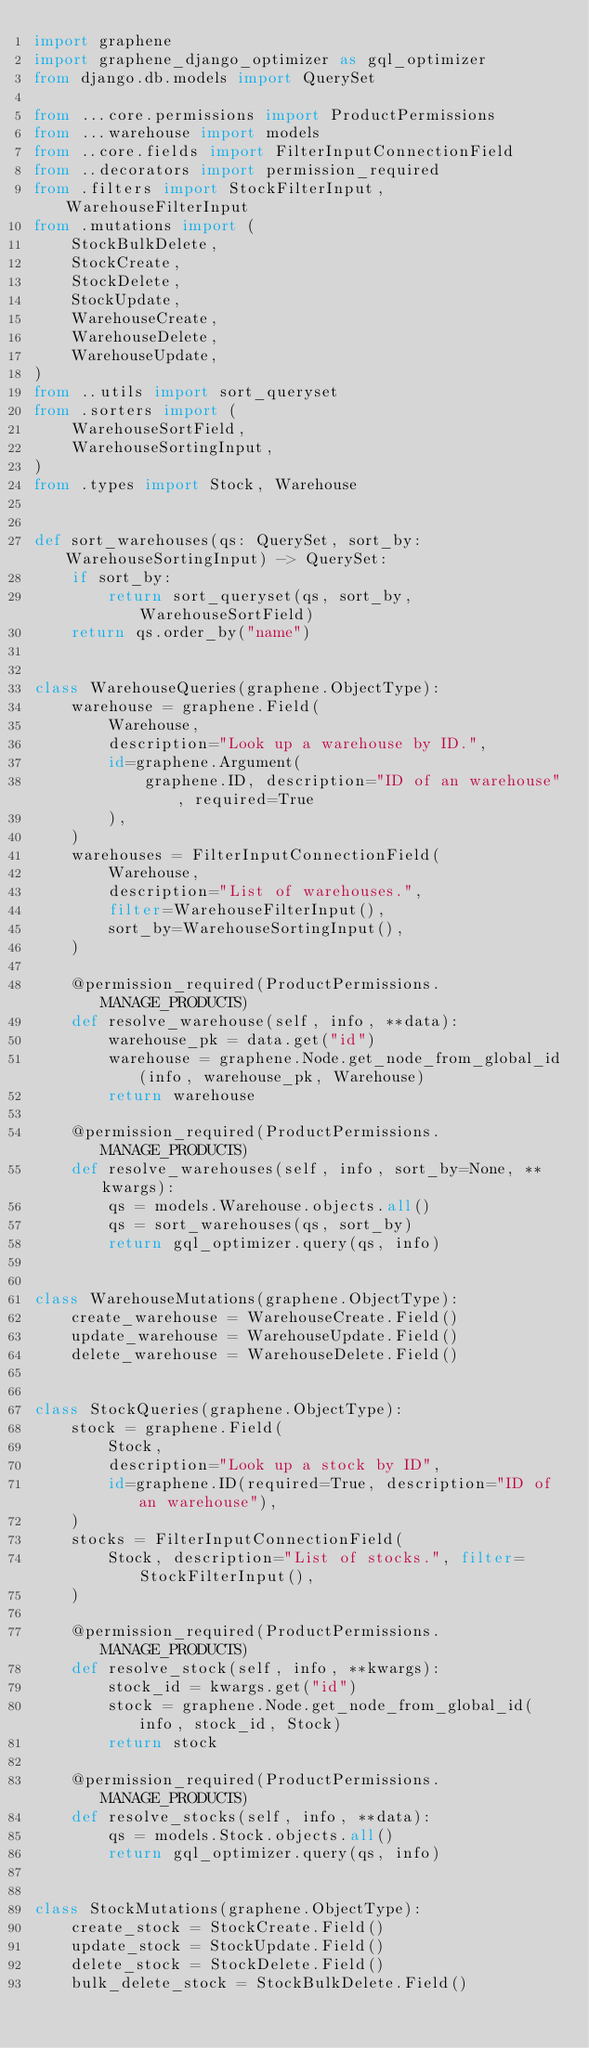<code> <loc_0><loc_0><loc_500><loc_500><_Python_>import graphene
import graphene_django_optimizer as gql_optimizer
from django.db.models import QuerySet

from ...core.permissions import ProductPermissions
from ...warehouse import models
from ..core.fields import FilterInputConnectionField
from ..decorators import permission_required
from .filters import StockFilterInput, WarehouseFilterInput
from .mutations import (
    StockBulkDelete,
    StockCreate,
    StockDelete,
    StockUpdate,
    WarehouseCreate,
    WarehouseDelete,
    WarehouseUpdate,
)
from ..utils import sort_queryset
from .sorters import (
    WarehouseSortField,
    WarehouseSortingInput,
)
from .types import Stock, Warehouse


def sort_warehouses(qs: QuerySet, sort_by: WarehouseSortingInput) -> QuerySet:
    if sort_by:
        return sort_queryset(qs, sort_by, WarehouseSortField)
    return qs.order_by("name")


class WarehouseQueries(graphene.ObjectType):
    warehouse = graphene.Field(
        Warehouse,
        description="Look up a warehouse by ID.",
        id=graphene.Argument(
            graphene.ID, description="ID of an warehouse", required=True
        ),
    )
    warehouses = FilterInputConnectionField(
        Warehouse,
        description="List of warehouses.",
        filter=WarehouseFilterInput(),
        sort_by=WarehouseSortingInput(),
    )

    @permission_required(ProductPermissions.MANAGE_PRODUCTS)
    def resolve_warehouse(self, info, **data):
        warehouse_pk = data.get("id")
        warehouse = graphene.Node.get_node_from_global_id(info, warehouse_pk, Warehouse)
        return warehouse

    @permission_required(ProductPermissions.MANAGE_PRODUCTS)
    def resolve_warehouses(self, info, sort_by=None, **kwargs):
        qs = models.Warehouse.objects.all()
        qs = sort_warehouses(qs, sort_by)
        return gql_optimizer.query(qs, info)


class WarehouseMutations(graphene.ObjectType):
    create_warehouse = WarehouseCreate.Field()
    update_warehouse = WarehouseUpdate.Field()
    delete_warehouse = WarehouseDelete.Field()


class StockQueries(graphene.ObjectType):
    stock = graphene.Field(
        Stock,
        description="Look up a stock by ID",
        id=graphene.ID(required=True, description="ID of an warehouse"),
    )
    stocks = FilterInputConnectionField(
        Stock, description="List of stocks.", filter=StockFilterInput(),
    )

    @permission_required(ProductPermissions.MANAGE_PRODUCTS)
    def resolve_stock(self, info, **kwargs):
        stock_id = kwargs.get("id")
        stock = graphene.Node.get_node_from_global_id(info, stock_id, Stock)
        return stock

    @permission_required(ProductPermissions.MANAGE_PRODUCTS)
    def resolve_stocks(self, info, **data):
        qs = models.Stock.objects.all()
        return gql_optimizer.query(qs, info)


class StockMutations(graphene.ObjectType):
    create_stock = StockCreate.Field()
    update_stock = StockUpdate.Field()
    delete_stock = StockDelete.Field()
    bulk_delete_stock = StockBulkDelete.Field()
</code> 